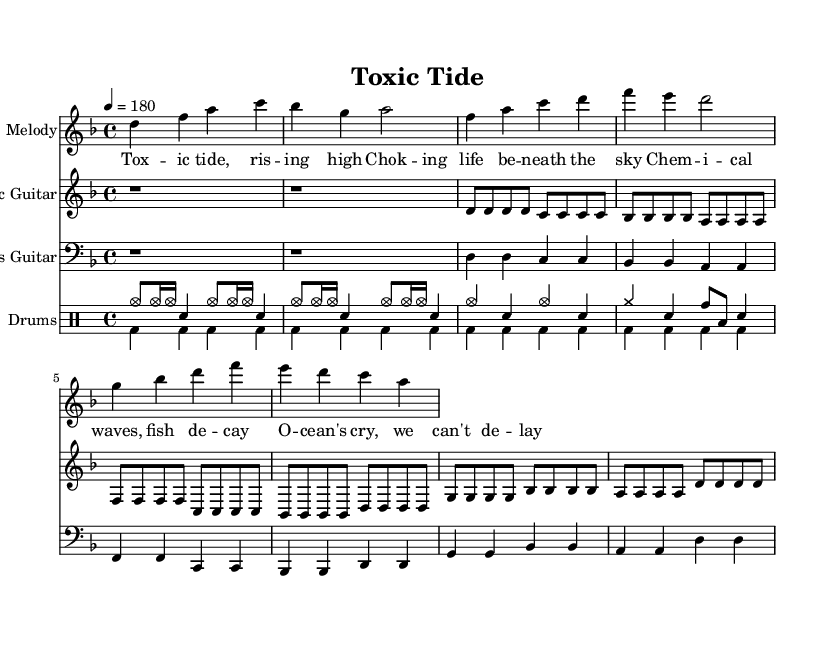What is the key signature of this music? The key signature indicated at the beginning of the score is D minor, which contains one flat (B flat).
Answer: D minor What is the time signature of the piece? The time signature is shown at the start of the score as 4/4, meaning there are four beats in each measure.
Answer: 4/4 What is the tempo marking for this piece? The tempo is indicated as 4 equals 180, suggesting a fast pace of 180 beats per minute.
Answer: 180 In which section do the lyrics "Toxic tide, rising high" appear? These lyrics appear in the chorus section of the song, as indicated by the corresponding lyrics and structure in the sheet music.
Answer: Chorus How many measures are there in the intro section? The intro section contains 2 measures, as represented by the two rests at the beginning of the score.
Answer: 2 What type of musical instrument is featured as the main melody? The main melody is played on the Electric Guitar, which is specified at the start of its respective staff.
Answer: Electric Guitar What theme does the song "Toxic Tide" address? The song addresses the theme of industrial waste impacting marine life, as indicated by the lyrics and the title.
Answer: Industrial waste 